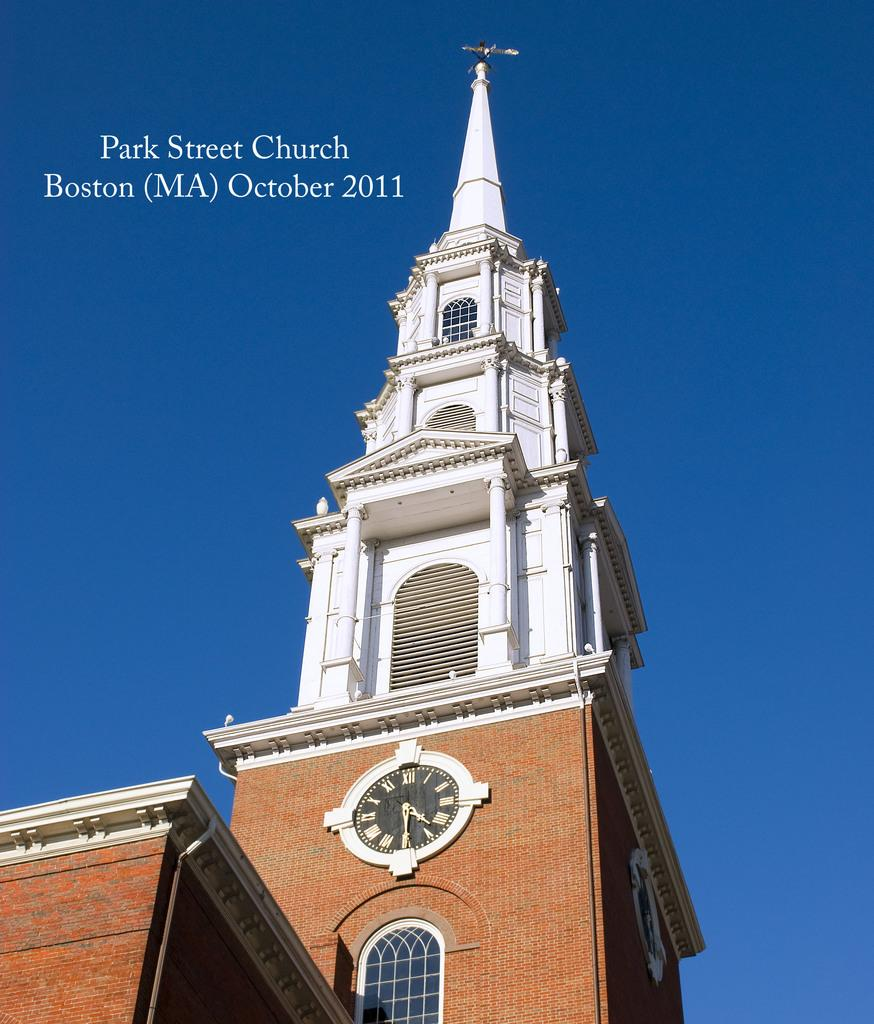What type of structure is present in the image? There is a building in the image. What can be seen on the wall inside the building? There is a clock on the wall in the image. What is visible in the background of the image? The sky is visible in the background of the image. Where is the basketball located in the image? There is no basketball present in the image. 